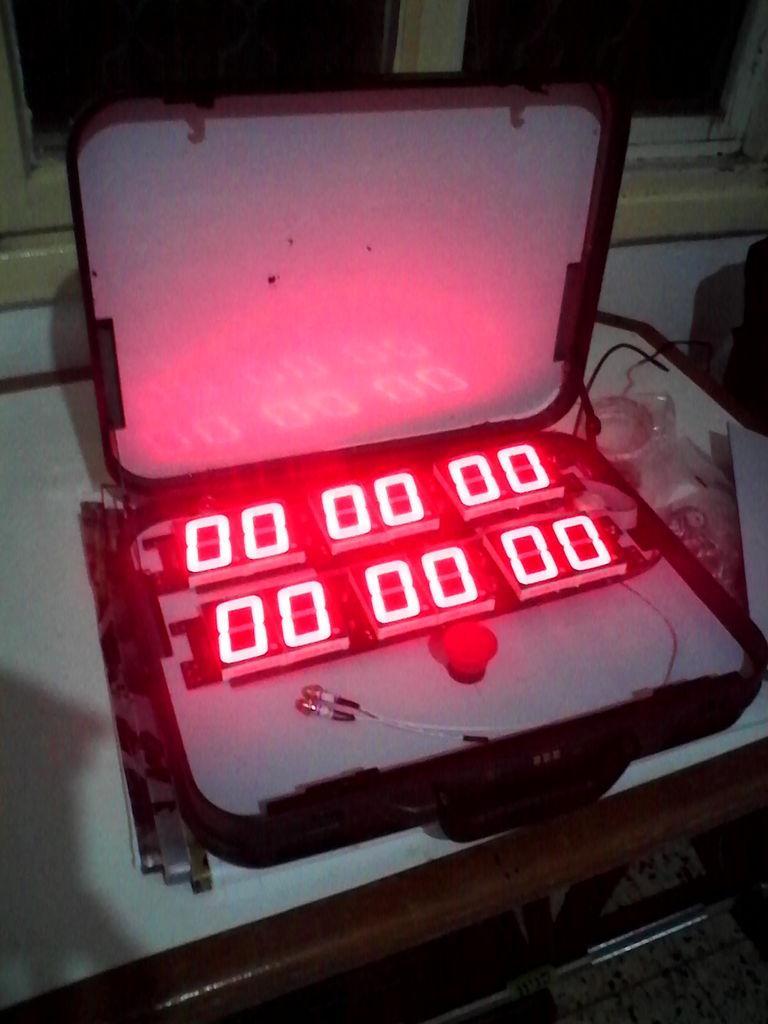Can you describe this image briefly? In this image we can see a led display inside the box. In the background we can see windows, desk and floor. 